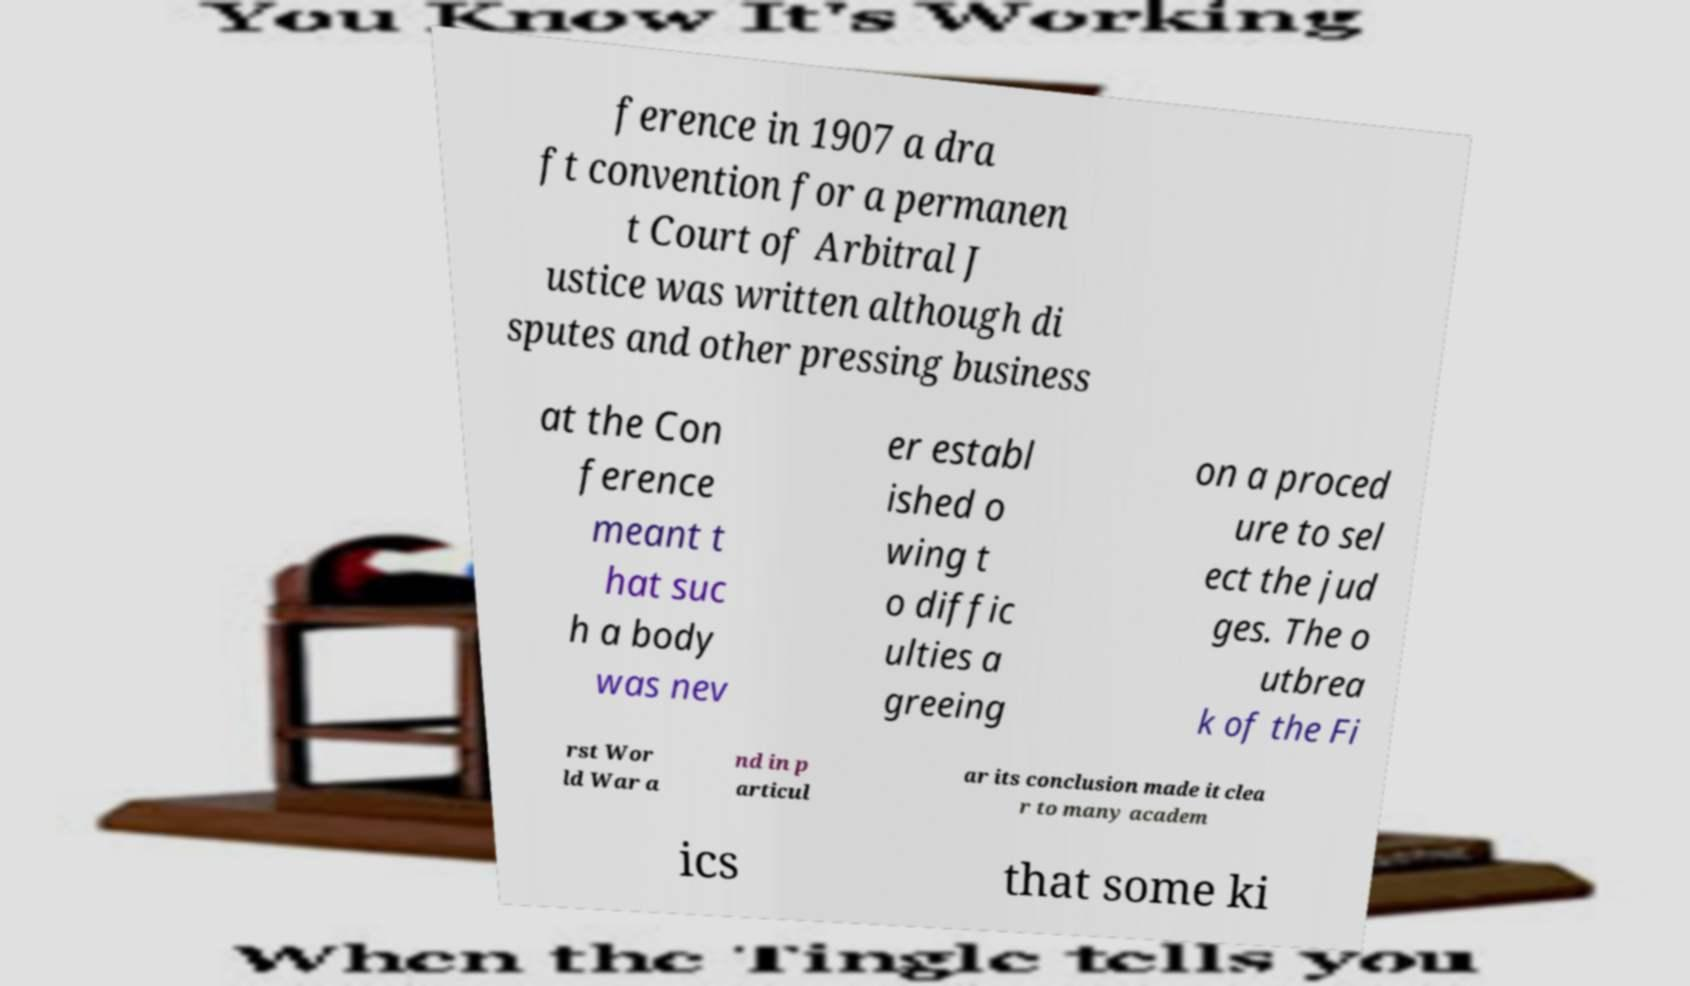Could you assist in decoding the text presented in this image and type it out clearly? ference in 1907 a dra ft convention for a permanen t Court of Arbitral J ustice was written although di sputes and other pressing business at the Con ference meant t hat suc h a body was nev er establ ished o wing t o diffic ulties a greeing on a proced ure to sel ect the jud ges. The o utbrea k of the Fi rst Wor ld War a nd in p articul ar its conclusion made it clea r to many academ ics that some ki 